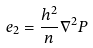Convert formula to latex. <formula><loc_0><loc_0><loc_500><loc_500>e _ { 2 } = \frac { h ^ { 2 } } { n } \nabla ^ { 2 } P</formula> 